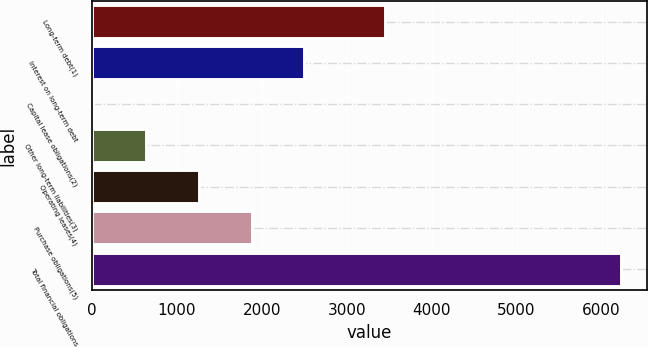Convert chart. <chart><loc_0><loc_0><loc_500><loc_500><bar_chart><fcel>Long-term debt(1)<fcel>Interest on long-term debt<fcel>Capital lease obligations(2)<fcel>Other long-term liabilities(3)<fcel>Operating leases(4)<fcel>Purchase obligations(5)<fcel>Total financial obligations<nl><fcel>3457.3<fcel>2503.38<fcel>19.5<fcel>640.47<fcel>1261.44<fcel>1882.41<fcel>6229.2<nl></chart> 